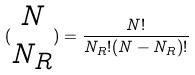<formula> <loc_0><loc_0><loc_500><loc_500>( \begin{matrix} N \\ N _ { R } \end{matrix} ) = \frac { N ! } { N _ { R } ! ( N - N _ { R } ) ! }</formula> 